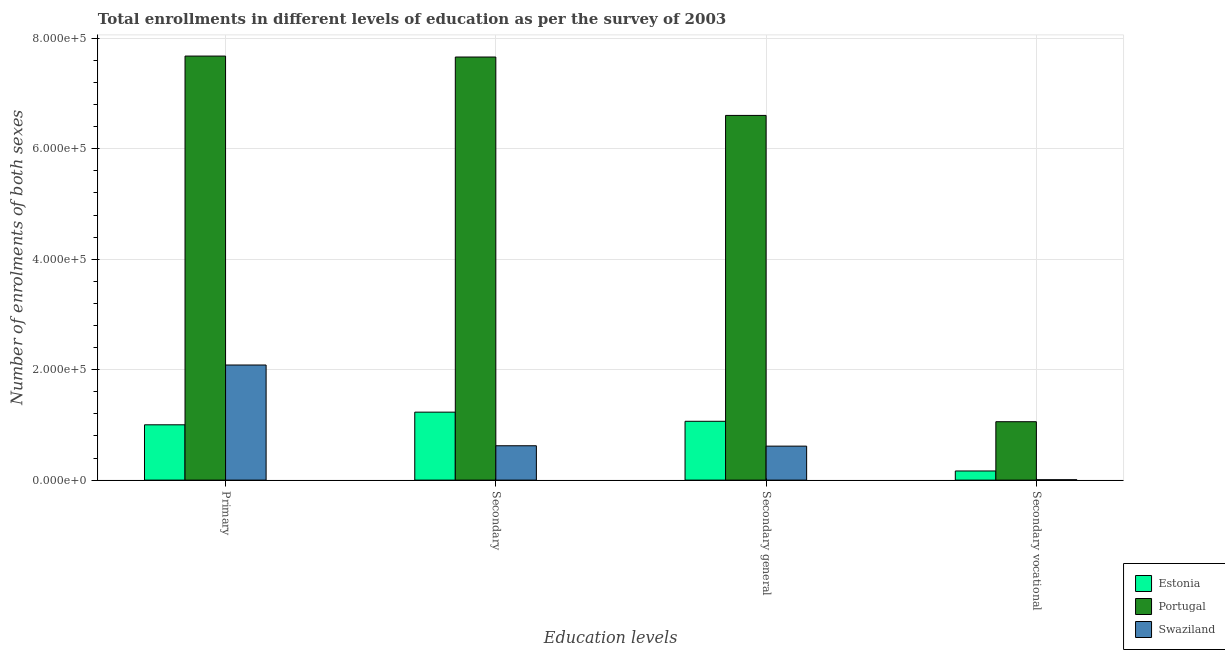How many different coloured bars are there?
Provide a short and direct response. 3. How many groups of bars are there?
Your answer should be very brief. 4. Are the number of bars on each tick of the X-axis equal?
Your answer should be very brief. Yes. What is the label of the 3rd group of bars from the left?
Your answer should be compact. Secondary general. What is the number of enrolments in secondary education in Estonia?
Offer a very short reply. 1.23e+05. Across all countries, what is the maximum number of enrolments in secondary education?
Your response must be concise. 7.66e+05. Across all countries, what is the minimum number of enrolments in primary education?
Offer a terse response. 1.00e+05. In which country was the number of enrolments in primary education maximum?
Make the answer very short. Portugal. In which country was the number of enrolments in secondary education minimum?
Offer a terse response. Swaziland. What is the total number of enrolments in secondary education in the graph?
Ensure brevity in your answer.  9.51e+05. What is the difference between the number of enrolments in primary education in Swaziland and that in Portugal?
Provide a succinct answer. -5.59e+05. What is the difference between the number of enrolments in secondary general education in Estonia and the number of enrolments in secondary vocational education in Swaziland?
Your answer should be very brief. 1.06e+05. What is the average number of enrolments in primary education per country?
Your response must be concise. 3.59e+05. What is the difference between the number of enrolments in primary education and number of enrolments in secondary general education in Portugal?
Offer a very short reply. 1.07e+05. What is the ratio of the number of enrolments in secondary general education in Portugal to that in Estonia?
Your answer should be very brief. 6.2. Is the difference between the number of enrolments in secondary vocational education in Swaziland and Estonia greater than the difference between the number of enrolments in secondary education in Swaziland and Estonia?
Give a very brief answer. Yes. What is the difference between the highest and the second highest number of enrolments in secondary vocational education?
Your answer should be compact. 8.92e+04. What is the difference between the highest and the lowest number of enrolments in primary education?
Provide a succinct answer. 6.68e+05. In how many countries, is the number of enrolments in primary education greater than the average number of enrolments in primary education taken over all countries?
Ensure brevity in your answer.  1. What does the 1st bar from the left in Secondary represents?
Your answer should be very brief. Estonia. What does the 1st bar from the right in Secondary general represents?
Your response must be concise. Swaziland. How many bars are there?
Provide a short and direct response. 12. Are all the bars in the graph horizontal?
Offer a very short reply. No. How many countries are there in the graph?
Your answer should be very brief. 3. Does the graph contain any zero values?
Provide a succinct answer. No. Where does the legend appear in the graph?
Offer a very short reply. Bottom right. How many legend labels are there?
Your answer should be compact. 3. How are the legend labels stacked?
Ensure brevity in your answer.  Vertical. What is the title of the graph?
Your answer should be compact. Total enrollments in different levels of education as per the survey of 2003. Does "Tonga" appear as one of the legend labels in the graph?
Keep it short and to the point. No. What is the label or title of the X-axis?
Offer a terse response. Education levels. What is the label or title of the Y-axis?
Your answer should be compact. Number of enrolments of both sexes. What is the Number of enrolments of both sexes of Estonia in Primary?
Keep it short and to the point. 1.00e+05. What is the Number of enrolments of both sexes of Portugal in Primary?
Ensure brevity in your answer.  7.68e+05. What is the Number of enrolments of both sexes of Swaziland in Primary?
Your response must be concise. 2.08e+05. What is the Number of enrolments of both sexes in Estonia in Secondary?
Provide a short and direct response. 1.23e+05. What is the Number of enrolments of both sexes in Portugal in Secondary?
Your response must be concise. 7.66e+05. What is the Number of enrolments of both sexes of Swaziland in Secondary?
Your response must be concise. 6.22e+04. What is the Number of enrolments of both sexes of Estonia in Secondary general?
Keep it short and to the point. 1.07e+05. What is the Number of enrolments of both sexes of Portugal in Secondary general?
Provide a succinct answer. 6.60e+05. What is the Number of enrolments of both sexes of Swaziland in Secondary general?
Make the answer very short. 6.15e+04. What is the Number of enrolments of both sexes in Estonia in Secondary vocational?
Provide a succinct answer. 1.65e+04. What is the Number of enrolments of both sexes of Portugal in Secondary vocational?
Your answer should be compact. 1.06e+05. What is the Number of enrolments of both sexes of Swaziland in Secondary vocational?
Your response must be concise. 686. Across all Education levels, what is the maximum Number of enrolments of both sexes in Estonia?
Provide a succinct answer. 1.23e+05. Across all Education levels, what is the maximum Number of enrolments of both sexes in Portugal?
Give a very brief answer. 7.68e+05. Across all Education levels, what is the maximum Number of enrolments of both sexes of Swaziland?
Ensure brevity in your answer.  2.08e+05. Across all Education levels, what is the minimum Number of enrolments of both sexes in Estonia?
Your response must be concise. 1.65e+04. Across all Education levels, what is the minimum Number of enrolments of both sexes in Portugal?
Your answer should be compact. 1.06e+05. Across all Education levels, what is the minimum Number of enrolments of both sexes in Swaziland?
Provide a succinct answer. 686. What is the total Number of enrolments of both sexes in Estonia in the graph?
Provide a succinct answer. 3.46e+05. What is the total Number of enrolments of both sexes in Portugal in the graph?
Give a very brief answer. 2.30e+06. What is the total Number of enrolments of both sexes in Swaziland in the graph?
Provide a short and direct response. 3.33e+05. What is the difference between the Number of enrolments of both sexes in Estonia in Primary and that in Secondary?
Your response must be concise. -2.29e+04. What is the difference between the Number of enrolments of both sexes of Portugal in Primary and that in Secondary?
Keep it short and to the point. 1700. What is the difference between the Number of enrolments of both sexes of Swaziland in Primary and that in Secondary?
Offer a very short reply. 1.46e+05. What is the difference between the Number of enrolments of both sexes of Estonia in Primary and that in Secondary general?
Make the answer very short. -6359. What is the difference between the Number of enrolments of both sexes of Portugal in Primary and that in Secondary general?
Your answer should be very brief. 1.07e+05. What is the difference between the Number of enrolments of both sexes in Swaziland in Primary and that in Secondary general?
Keep it short and to the point. 1.47e+05. What is the difference between the Number of enrolments of both sexes in Estonia in Primary and that in Secondary vocational?
Your response must be concise. 8.36e+04. What is the difference between the Number of enrolments of both sexes of Portugal in Primary and that in Secondary vocational?
Your response must be concise. 6.62e+05. What is the difference between the Number of enrolments of both sexes in Swaziland in Primary and that in Secondary vocational?
Your answer should be very brief. 2.08e+05. What is the difference between the Number of enrolments of both sexes in Estonia in Secondary and that in Secondary general?
Your answer should be very brief. 1.65e+04. What is the difference between the Number of enrolments of both sexes of Portugal in Secondary and that in Secondary general?
Make the answer very short. 1.06e+05. What is the difference between the Number of enrolments of both sexes in Swaziland in Secondary and that in Secondary general?
Keep it short and to the point. 686. What is the difference between the Number of enrolments of both sexes of Estonia in Secondary and that in Secondary vocational?
Provide a succinct answer. 1.07e+05. What is the difference between the Number of enrolments of both sexes in Portugal in Secondary and that in Secondary vocational?
Offer a very short reply. 6.60e+05. What is the difference between the Number of enrolments of both sexes in Swaziland in Secondary and that in Secondary vocational?
Ensure brevity in your answer.  6.15e+04. What is the difference between the Number of enrolments of both sexes in Estonia in Secondary general and that in Secondary vocational?
Give a very brief answer. 9.00e+04. What is the difference between the Number of enrolments of both sexes in Portugal in Secondary general and that in Secondary vocational?
Provide a succinct answer. 5.55e+05. What is the difference between the Number of enrolments of both sexes in Swaziland in Secondary general and that in Secondary vocational?
Your response must be concise. 6.08e+04. What is the difference between the Number of enrolments of both sexes in Estonia in Primary and the Number of enrolments of both sexes in Portugal in Secondary?
Your response must be concise. -6.66e+05. What is the difference between the Number of enrolments of both sexes of Estonia in Primary and the Number of enrolments of both sexes of Swaziland in Secondary?
Your response must be concise. 3.80e+04. What is the difference between the Number of enrolments of both sexes of Portugal in Primary and the Number of enrolments of both sexes of Swaziland in Secondary?
Offer a terse response. 7.06e+05. What is the difference between the Number of enrolments of both sexes in Estonia in Primary and the Number of enrolments of both sexes in Portugal in Secondary general?
Ensure brevity in your answer.  -5.60e+05. What is the difference between the Number of enrolments of both sexes of Estonia in Primary and the Number of enrolments of both sexes of Swaziland in Secondary general?
Make the answer very short. 3.86e+04. What is the difference between the Number of enrolments of both sexes in Portugal in Primary and the Number of enrolments of both sexes in Swaziland in Secondary general?
Offer a very short reply. 7.06e+05. What is the difference between the Number of enrolments of both sexes in Estonia in Primary and the Number of enrolments of both sexes in Portugal in Secondary vocational?
Keep it short and to the point. -5582. What is the difference between the Number of enrolments of both sexes of Estonia in Primary and the Number of enrolments of both sexes of Swaziland in Secondary vocational?
Provide a short and direct response. 9.95e+04. What is the difference between the Number of enrolments of both sexes of Portugal in Primary and the Number of enrolments of both sexes of Swaziland in Secondary vocational?
Give a very brief answer. 7.67e+05. What is the difference between the Number of enrolments of both sexes of Estonia in Secondary and the Number of enrolments of both sexes of Portugal in Secondary general?
Your answer should be very brief. -5.37e+05. What is the difference between the Number of enrolments of both sexes in Estonia in Secondary and the Number of enrolments of both sexes in Swaziland in Secondary general?
Ensure brevity in your answer.  6.15e+04. What is the difference between the Number of enrolments of both sexes of Portugal in Secondary and the Number of enrolments of both sexes of Swaziland in Secondary general?
Provide a succinct answer. 7.05e+05. What is the difference between the Number of enrolments of both sexes in Estonia in Secondary and the Number of enrolments of both sexes in Portugal in Secondary vocational?
Keep it short and to the point. 1.73e+04. What is the difference between the Number of enrolments of both sexes in Estonia in Secondary and the Number of enrolments of both sexes in Swaziland in Secondary vocational?
Your response must be concise. 1.22e+05. What is the difference between the Number of enrolments of both sexes of Portugal in Secondary and the Number of enrolments of both sexes of Swaziland in Secondary vocational?
Give a very brief answer. 7.65e+05. What is the difference between the Number of enrolments of both sexes in Estonia in Secondary general and the Number of enrolments of both sexes in Portugal in Secondary vocational?
Ensure brevity in your answer.  777. What is the difference between the Number of enrolments of both sexes of Estonia in Secondary general and the Number of enrolments of both sexes of Swaziland in Secondary vocational?
Ensure brevity in your answer.  1.06e+05. What is the difference between the Number of enrolments of both sexes in Portugal in Secondary general and the Number of enrolments of both sexes in Swaziland in Secondary vocational?
Give a very brief answer. 6.60e+05. What is the average Number of enrolments of both sexes of Estonia per Education levels?
Make the answer very short. 8.66e+04. What is the average Number of enrolments of both sexes of Portugal per Education levels?
Ensure brevity in your answer.  5.75e+05. What is the average Number of enrolments of both sexes of Swaziland per Education levels?
Offer a terse response. 8.32e+04. What is the difference between the Number of enrolments of both sexes in Estonia and Number of enrolments of both sexes in Portugal in Primary?
Your answer should be compact. -6.68e+05. What is the difference between the Number of enrolments of both sexes in Estonia and Number of enrolments of both sexes in Swaziland in Primary?
Provide a short and direct response. -1.08e+05. What is the difference between the Number of enrolments of both sexes of Portugal and Number of enrolments of both sexes of Swaziland in Primary?
Offer a very short reply. 5.59e+05. What is the difference between the Number of enrolments of both sexes in Estonia and Number of enrolments of both sexes in Portugal in Secondary?
Offer a very short reply. -6.43e+05. What is the difference between the Number of enrolments of both sexes of Estonia and Number of enrolments of both sexes of Swaziland in Secondary?
Offer a very short reply. 6.09e+04. What is the difference between the Number of enrolments of both sexes in Portugal and Number of enrolments of both sexes in Swaziland in Secondary?
Your answer should be compact. 7.04e+05. What is the difference between the Number of enrolments of both sexes in Estonia and Number of enrolments of both sexes in Portugal in Secondary general?
Provide a succinct answer. -5.54e+05. What is the difference between the Number of enrolments of both sexes in Estonia and Number of enrolments of both sexes in Swaziland in Secondary general?
Provide a short and direct response. 4.50e+04. What is the difference between the Number of enrolments of both sexes in Portugal and Number of enrolments of both sexes in Swaziland in Secondary general?
Offer a terse response. 5.99e+05. What is the difference between the Number of enrolments of both sexes in Estonia and Number of enrolments of both sexes in Portugal in Secondary vocational?
Your answer should be very brief. -8.92e+04. What is the difference between the Number of enrolments of both sexes of Estonia and Number of enrolments of both sexes of Swaziland in Secondary vocational?
Make the answer very short. 1.59e+04. What is the difference between the Number of enrolments of both sexes in Portugal and Number of enrolments of both sexes in Swaziland in Secondary vocational?
Provide a short and direct response. 1.05e+05. What is the ratio of the Number of enrolments of both sexes of Estonia in Primary to that in Secondary?
Your answer should be very brief. 0.81. What is the ratio of the Number of enrolments of both sexes in Portugal in Primary to that in Secondary?
Keep it short and to the point. 1. What is the ratio of the Number of enrolments of both sexes in Swaziland in Primary to that in Secondary?
Your response must be concise. 3.35. What is the ratio of the Number of enrolments of both sexes of Estonia in Primary to that in Secondary general?
Make the answer very short. 0.94. What is the ratio of the Number of enrolments of both sexes in Portugal in Primary to that in Secondary general?
Offer a terse response. 1.16. What is the ratio of the Number of enrolments of both sexes of Swaziland in Primary to that in Secondary general?
Ensure brevity in your answer.  3.39. What is the ratio of the Number of enrolments of both sexes in Estonia in Primary to that in Secondary vocational?
Your response must be concise. 6.05. What is the ratio of the Number of enrolments of both sexes in Portugal in Primary to that in Secondary vocational?
Give a very brief answer. 7.26. What is the ratio of the Number of enrolments of both sexes in Swaziland in Primary to that in Secondary vocational?
Keep it short and to the point. 303.85. What is the ratio of the Number of enrolments of both sexes in Estonia in Secondary to that in Secondary general?
Provide a short and direct response. 1.16. What is the ratio of the Number of enrolments of both sexes in Portugal in Secondary to that in Secondary general?
Your answer should be compact. 1.16. What is the ratio of the Number of enrolments of both sexes in Swaziland in Secondary to that in Secondary general?
Your answer should be very brief. 1.01. What is the ratio of the Number of enrolments of both sexes in Estonia in Secondary to that in Secondary vocational?
Make the answer very short. 7.44. What is the ratio of the Number of enrolments of both sexes in Portugal in Secondary to that in Secondary vocational?
Your answer should be very brief. 7.24. What is the ratio of the Number of enrolments of both sexes in Swaziland in Secondary to that in Secondary vocational?
Offer a very short reply. 90.69. What is the ratio of the Number of enrolments of both sexes in Estonia in Secondary general to that in Secondary vocational?
Provide a succinct answer. 6.44. What is the ratio of the Number of enrolments of both sexes of Portugal in Secondary general to that in Secondary vocational?
Provide a short and direct response. 6.24. What is the ratio of the Number of enrolments of both sexes in Swaziland in Secondary general to that in Secondary vocational?
Make the answer very short. 89.69. What is the difference between the highest and the second highest Number of enrolments of both sexes of Estonia?
Make the answer very short. 1.65e+04. What is the difference between the highest and the second highest Number of enrolments of both sexes of Portugal?
Ensure brevity in your answer.  1700. What is the difference between the highest and the second highest Number of enrolments of both sexes of Swaziland?
Make the answer very short. 1.46e+05. What is the difference between the highest and the lowest Number of enrolments of both sexes of Estonia?
Keep it short and to the point. 1.07e+05. What is the difference between the highest and the lowest Number of enrolments of both sexes in Portugal?
Provide a succinct answer. 6.62e+05. What is the difference between the highest and the lowest Number of enrolments of both sexes of Swaziland?
Give a very brief answer. 2.08e+05. 